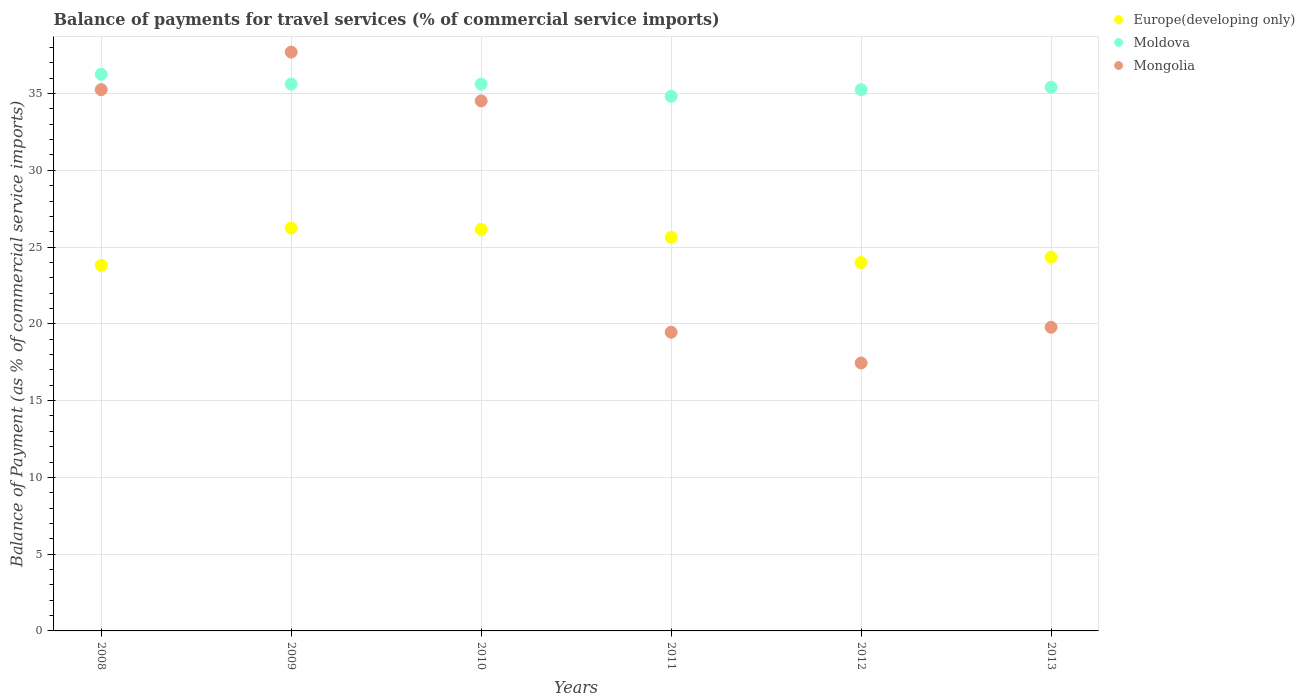What is the balance of payments for travel services in Europe(developing only) in 2009?
Your answer should be very brief. 26.24. Across all years, what is the maximum balance of payments for travel services in Moldova?
Keep it short and to the point. 36.26. Across all years, what is the minimum balance of payments for travel services in Moldova?
Provide a short and direct response. 34.82. In which year was the balance of payments for travel services in Europe(developing only) minimum?
Provide a succinct answer. 2008. What is the total balance of payments for travel services in Mongolia in the graph?
Make the answer very short. 164.17. What is the difference between the balance of payments for travel services in Mongolia in 2008 and that in 2013?
Your response must be concise. 15.47. What is the difference between the balance of payments for travel services in Europe(developing only) in 2012 and the balance of payments for travel services in Mongolia in 2010?
Ensure brevity in your answer.  -10.53. What is the average balance of payments for travel services in Moldova per year?
Offer a very short reply. 35.5. In the year 2010, what is the difference between the balance of payments for travel services in Europe(developing only) and balance of payments for travel services in Mongolia?
Offer a very short reply. -8.37. What is the ratio of the balance of payments for travel services in Europe(developing only) in 2008 to that in 2010?
Provide a succinct answer. 0.91. Is the balance of payments for travel services in Moldova in 2012 less than that in 2013?
Give a very brief answer. Yes. What is the difference between the highest and the second highest balance of payments for travel services in Moldova?
Your answer should be compact. 0.64. What is the difference between the highest and the lowest balance of payments for travel services in Mongolia?
Give a very brief answer. 20.25. Is it the case that in every year, the sum of the balance of payments for travel services in Mongolia and balance of payments for travel services in Europe(developing only)  is greater than the balance of payments for travel services in Moldova?
Your answer should be very brief. Yes. Is the balance of payments for travel services in Moldova strictly less than the balance of payments for travel services in Europe(developing only) over the years?
Keep it short and to the point. No. How many dotlines are there?
Provide a short and direct response. 3. Does the graph contain grids?
Ensure brevity in your answer.  Yes. What is the title of the graph?
Keep it short and to the point. Balance of payments for travel services (% of commercial service imports). What is the label or title of the Y-axis?
Ensure brevity in your answer.  Balance of Payment (as % of commercial service imports). What is the Balance of Payment (as % of commercial service imports) of Europe(developing only) in 2008?
Your answer should be very brief. 23.81. What is the Balance of Payment (as % of commercial service imports) of Moldova in 2008?
Offer a terse response. 36.26. What is the Balance of Payment (as % of commercial service imports) in Mongolia in 2008?
Give a very brief answer. 35.26. What is the Balance of Payment (as % of commercial service imports) in Europe(developing only) in 2009?
Your answer should be compact. 26.24. What is the Balance of Payment (as % of commercial service imports) in Moldova in 2009?
Your answer should be compact. 35.62. What is the Balance of Payment (as % of commercial service imports) in Mongolia in 2009?
Give a very brief answer. 37.7. What is the Balance of Payment (as % of commercial service imports) in Europe(developing only) in 2010?
Offer a very short reply. 26.15. What is the Balance of Payment (as % of commercial service imports) in Moldova in 2010?
Offer a very short reply. 35.61. What is the Balance of Payment (as % of commercial service imports) of Mongolia in 2010?
Ensure brevity in your answer.  34.52. What is the Balance of Payment (as % of commercial service imports) of Europe(developing only) in 2011?
Offer a terse response. 25.63. What is the Balance of Payment (as % of commercial service imports) in Moldova in 2011?
Provide a succinct answer. 34.82. What is the Balance of Payment (as % of commercial service imports) of Mongolia in 2011?
Offer a terse response. 19.45. What is the Balance of Payment (as % of commercial service imports) of Europe(developing only) in 2012?
Your answer should be compact. 24. What is the Balance of Payment (as % of commercial service imports) in Moldova in 2012?
Provide a succinct answer. 35.25. What is the Balance of Payment (as % of commercial service imports) of Mongolia in 2012?
Provide a short and direct response. 17.45. What is the Balance of Payment (as % of commercial service imports) of Europe(developing only) in 2013?
Provide a short and direct response. 24.35. What is the Balance of Payment (as % of commercial service imports) of Moldova in 2013?
Provide a succinct answer. 35.42. What is the Balance of Payment (as % of commercial service imports) of Mongolia in 2013?
Your response must be concise. 19.78. Across all years, what is the maximum Balance of Payment (as % of commercial service imports) of Europe(developing only)?
Ensure brevity in your answer.  26.24. Across all years, what is the maximum Balance of Payment (as % of commercial service imports) of Moldova?
Provide a succinct answer. 36.26. Across all years, what is the maximum Balance of Payment (as % of commercial service imports) of Mongolia?
Keep it short and to the point. 37.7. Across all years, what is the minimum Balance of Payment (as % of commercial service imports) in Europe(developing only)?
Give a very brief answer. 23.81. Across all years, what is the minimum Balance of Payment (as % of commercial service imports) of Moldova?
Offer a terse response. 34.82. Across all years, what is the minimum Balance of Payment (as % of commercial service imports) in Mongolia?
Offer a very short reply. 17.45. What is the total Balance of Payment (as % of commercial service imports) of Europe(developing only) in the graph?
Offer a terse response. 150.17. What is the total Balance of Payment (as % of commercial service imports) in Moldova in the graph?
Provide a succinct answer. 212.97. What is the total Balance of Payment (as % of commercial service imports) of Mongolia in the graph?
Ensure brevity in your answer.  164.17. What is the difference between the Balance of Payment (as % of commercial service imports) of Europe(developing only) in 2008 and that in 2009?
Your answer should be compact. -2.43. What is the difference between the Balance of Payment (as % of commercial service imports) of Moldova in 2008 and that in 2009?
Make the answer very short. 0.64. What is the difference between the Balance of Payment (as % of commercial service imports) of Mongolia in 2008 and that in 2009?
Provide a succinct answer. -2.44. What is the difference between the Balance of Payment (as % of commercial service imports) in Europe(developing only) in 2008 and that in 2010?
Make the answer very short. -2.35. What is the difference between the Balance of Payment (as % of commercial service imports) in Moldova in 2008 and that in 2010?
Offer a very short reply. 0.64. What is the difference between the Balance of Payment (as % of commercial service imports) of Mongolia in 2008 and that in 2010?
Keep it short and to the point. 0.73. What is the difference between the Balance of Payment (as % of commercial service imports) in Europe(developing only) in 2008 and that in 2011?
Ensure brevity in your answer.  -1.82. What is the difference between the Balance of Payment (as % of commercial service imports) in Moldova in 2008 and that in 2011?
Your answer should be very brief. 1.44. What is the difference between the Balance of Payment (as % of commercial service imports) in Mongolia in 2008 and that in 2011?
Give a very brief answer. 15.8. What is the difference between the Balance of Payment (as % of commercial service imports) in Europe(developing only) in 2008 and that in 2012?
Your response must be concise. -0.19. What is the difference between the Balance of Payment (as % of commercial service imports) in Moldova in 2008 and that in 2012?
Provide a short and direct response. 1. What is the difference between the Balance of Payment (as % of commercial service imports) of Mongolia in 2008 and that in 2012?
Keep it short and to the point. 17.8. What is the difference between the Balance of Payment (as % of commercial service imports) in Europe(developing only) in 2008 and that in 2013?
Offer a very short reply. -0.54. What is the difference between the Balance of Payment (as % of commercial service imports) in Moldova in 2008 and that in 2013?
Make the answer very short. 0.84. What is the difference between the Balance of Payment (as % of commercial service imports) of Mongolia in 2008 and that in 2013?
Your answer should be very brief. 15.47. What is the difference between the Balance of Payment (as % of commercial service imports) in Europe(developing only) in 2009 and that in 2010?
Offer a terse response. 0.08. What is the difference between the Balance of Payment (as % of commercial service imports) in Moldova in 2009 and that in 2010?
Ensure brevity in your answer.  0. What is the difference between the Balance of Payment (as % of commercial service imports) of Mongolia in 2009 and that in 2010?
Offer a terse response. 3.18. What is the difference between the Balance of Payment (as % of commercial service imports) in Europe(developing only) in 2009 and that in 2011?
Provide a succinct answer. 0.61. What is the difference between the Balance of Payment (as % of commercial service imports) in Moldova in 2009 and that in 2011?
Provide a succinct answer. 0.8. What is the difference between the Balance of Payment (as % of commercial service imports) of Mongolia in 2009 and that in 2011?
Offer a very short reply. 18.25. What is the difference between the Balance of Payment (as % of commercial service imports) of Europe(developing only) in 2009 and that in 2012?
Make the answer very short. 2.24. What is the difference between the Balance of Payment (as % of commercial service imports) in Moldova in 2009 and that in 2012?
Offer a terse response. 0.37. What is the difference between the Balance of Payment (as % of commercial service imports) in Mongolia in 2009 and that in 2012?
Provide a short and direct response. 20.25. What is the difference between the Balance of Payment (as % of commercial service imports) of Europe(developing only) in 2009 and that in 2013?
Give a very brief answer. 1.89. What is the difference between the Balance of Payment (as % of commercial service imports) in Moldova in 2009 and that in 2013?
Your answer should be very brief. 0.2. What is the difference between the Balance of Payment (as % of commercial service imports) in Mongolia in 2009 and that in 2013?
Keep it short and to the point. 17.92. What is the difference between the Balance of Payment (as % of commercial service imports) of Europe(developing only) in 2010 and that in 2011?
Keep it short and to the point. 0.53. What is the difference between the Balance of Payment (as % of commercial service imports) of Moldova in 2010 and that in 2011?
Your answer should be very brief. 0.8. What is the difference between the Balance of Payment (as % of commercial service imports) in Mongolia in 2010 and that in 2011?
Offer a very short reply. 15.07. What is the difference between the Balance of Payment (as % of commercial service imports) of Europe(developing only) in 2010 and that in 2012?
Provide a succinct answer. 2.16. What is the difference between the Balance of Payment (as % of commercial service imports) of Moldova in 2010 and that in 2012?
Give a very brief answer. 0.36. What is the difference between the Balance of Payment (as % of commercial service imports) in Mongolia in 2010 and that in 2012?
Provide a short and direct response. 17.07. What is the difference between the Balance of Payment (as % of commercial service imports) of Europe(developing only) in 2010 and that in 2013?
Offer a terse response. 1.81. What is the difference between the Balance of Payment (as % of commercial service imports) of Moldova in 2010 and that in 2013?
Your answer should be very brief. 0.2. What is the difference between the Balance of Payment (as % of commercial service imports) of Mongolia in 2010 and that in 2013?
Your answer should be compact. 14.74. What is the difference between the Balance of Payment (as % of commercial service imports) in Europe(developing only) in 2011 and that in 2012?
Your answer should be very brief. 1.63. What is the difference between the Balance of Payment (as % of commercial service imports) of Moldova in 2011 and that in 2012?
Your response must be concise. -0.43. What is the difference between the Balance of Payment (as % of commercial service imports) of Mongolia in 2011 and that in 2012?
Give a very brief answer. 2. What is the difference between the Balance of Payment (as % of commercial service imports) in Europe(developing only) in 2011 and that in 2013?
Your answer should be very brief. 1.28. What is the difference between the Balance of Payment (as % of commercial service imports) in Moldova in 2011 and that in 2013?
Offer a terse response. -0.6. What is the difference between the Balance of Payment (as % of commercial service imports) of Mongolia in 2011 and that in 2013?
Ensure brevity in your answer.  -0.33. What is the difference between the Balance of Payment (as % of commercial service imports) of Europe(developing only) in 2012 and that in 2013?
Give a very brief answer. -0.35. What is the difference between the Balance of Payment (as % of commercial service imports) in Moldova in 2012 and that in 2013?
Your answer should be compact. -0.17. What is the difference between the Balance of Payment (as % of commercial service imports) in Mongolia in 2012 and that in 2013?
Give a very brief answer. -2.33. What is the difference between the Balance of Payment (as % of commercial service imports) in Europe(developing only) in 2008 and the Balance of Payment (as % of commercial service imports) in Moldova in 2009?
Offer a very short reply. -11.81. What is the difference between the Balance of Payment (as % of commercial service imports) in Europe(developing only) in 2008 and the Balance of Payment (as % of commercial service imports) in Mongolia in 2009?
Keep it short and to the point. -13.89. What is the difference between the Balance of Payment (as % of commercial service imports) of Moldova in 2008 and the Balance of Payment (as % of commercial service imports) of Mongolia in 2009?
Offer a terse response. -1.45. What is the difference between the Balance of Payment (as % of commercial service imports) of Europe(developing only) in 2008 and the Balance of Payment (as % of commercial service imports) of Moldova in 2010?
Make the answer very short. -11.8. What is the difference between the Balance of Payment (as % of commercial service imports) in Europe(developing only) in 2008 and the Balance of Payment (as % of commercial service imports) in Mongolia in 2010?
Make the answer very short. -10.72. What is the difference between the Balance of Payment (as % of commercial service imports) of Moldova in 2008 and the Balance of Payment (as % of commercial service imports) of Mongolia in 2010?
Your response must be concise. 1.73. What is the difference between the Balance of Payment (as % of commercial service imports) in Europe(developing only) in 2008 and the Balance of Payment (as % of commercial service imports) in Moldova in 2011?
Offer a terse response. -11.01. What is the difference between the Balance of Payment (as % of commercial service imports) of Europe(developing only) in 2008 and the Balance of Payment (as % of commercial service imports) of Mongolia in 2011?
Your answer should be compact. 4.36. What is the difference between the Balance of Payment (as % of commercial service imports) in Moldova in 2008 and the Balance of Payment (as % of commercial service imports) in Mongolia in 2011?
Keep it short and to the point. 16.8. What is the difference between the Balance of Payment (as % of commercial service imports) in Europe(developing only) in 2008 and the Balance of Payment (as % of commercial service imports) in Moldova in 2012?
Provide a short and direct response. -11.44. What is the difference between the Balance of Payment (as % of commercial service imports) of Europe(developing only) in 2008 and the Balance of Payment (as % of commercial service imports) of Mongolia in 2012?
Offer a terse response. 6.36. What is the difference between the Balance of Payment (as % of commercial service imports) of Moldova in 2008 and the Balance of Payment (as % of commercial service imports) of Mongolia in 2012?
Give a very brief answer. 18.8. What is the difference between the Balance of Payment (as % of commercial service imports) of Europe(developing only) in 2008 and the Balance of Payment (as % of commercial service imports) of Moldova in 2013?
Keep it short and to the point. -11.61. What is the difference between the Balance of Payment (as % of commercial service imports) of Europe(developing only) in 2008 and the Balance of Payment (as % of commercial service imports) of Mongolia in 2013?
Provide a succinct answer. 4.03. What is the difference between the Balance of Payment (as % of commercial service imports) in Moldova in 2008 and the Balance of Payment (as % of commercial service imports) in Mongolia in 2013?
Your response must be concise. 16.47. What is the difference between the Balance of Payment (as % of commercial service imports) of Europe(developing only) in 2009 and the Balance of Payment (as % of commercial service imports) of Moldova in 2010?
Your answer should be very brief. -9.38. What is the difference between the Balance of Payment (as % of commercial service imports) in Europe(developing only) in 2009 and the Balance of Payment (as % of commercial service imports) in Mongolia in 2010?
Give a very brief answer. -8.29. What is the difference between the Balance of Payment (as % of commercial service imports) of Moldova in 2009 and the Balance of Payment (as % of commercial service imports) of Mongolia in 2010?
Give a very brief answer. 1.09. What is the difference between the Balance of Payment (as % of commercial service imports) in Europe(developing only) in 2009 and the Balance of Payment (as % of commercial service imports) in Moldova in 2011?
Your response must be concise. -8.58. What is the difference between the Balance of Payment (as % of commercial service imports) in Europe(developing only) in 2009 and the Balance of Payment (as % of commercial service imports) in Mongolia in 2011?
Make the answer very short. 6.78. What is the difference between the Balance of Payment (as % of commercial service imports) of Moldova in 2009 and the Balance of Payment (as % of commercial service imports) of Mongolia in 2011?
Your answer should be very brief. 16.16. What is the difference between the Balance of Payment (as % of commercial service imports) in Europe(developing only) in 2009 and the Balance of Payment (as % of commercial service imports) in Moldova in 2012?
Offer a terse response. -9.01. What is the difference between the Balance of Payment (as % of commercial service imports) of Europe(developing only) in 2009 and the Balance of Payment (as % of commercial service imports) of Mongolia in 2012?
Give a very brief answer. 8.78. What is the difference between the Balance of Payment (as % of commercial service imports) in Moldova in 2009 and the Balance of Payment (as % of commercial service imports) in Mongolia in 2012?
Make the answer very short. 18.17. What is the difference between the Balance of Payment (as % of commercial service imports) of Europe(developing only) in 2009 and the Balance of Payment (as % of commercial service imports) of Moldova in 2013?
Keep it short and to the point. -9.18. What is the difference between the Balance of Payment (as % of commercial service imports) of Europe(developing only) in 2009 and the Balance of Payment (as % of commercial service imports) of Mongolia in 2013?
Your answer should be compact. 6.46. What is the difference between the Balance of Payment (as % of commercial service imports) of Moldova in 2009 and the Balance of Payment (as % of commercial service imports) of Mongolia in 2013?
Your answer should be compact. 15.84. What is the difference between the Balance of Payment (as % of commercial service imports) in Europe(developing only) in 2010 and the Balance of Payment (as % of commercial service imports) in Moldova in 2011?
Keep it short and to the point. -8.66. What is the difference between the Balance of Payment (as % of commercial service imports) of Europe(developing only) in 2010 and the Balance of Payment (as % of commercial service imports) of Mongolia in 2011?
Keep it short and to the point. 6.7. What is the difference between the Balance of Payment (as % of commercial service imports) in Moldova in 2010 and the Balance of Payment (as % of commercial service imports) in Mongolia in 2011?
Provide a short and direct response. 16.16. What is the difference between the Balance of Payment (as % of commercial service imports) of Europe(developing only) in 2010 and the Balance of Payment (as % of commercial service imports) of Moldova in 2012?
Keep it short and to the point. -9.1. What is the difference between the Balance of Payment (as % of commercial service imports) of Europe(developing only) in 2010 and the Balance of Payment (as % of commercial service imports) of Mongolia in 2012?
Keep it short and to the point. 8.7. What is the difference between the Balance of Payment (as % of commercial service imports) in Moldova in 2010 and the Balance of Payment (as % of commercial service imports) in Mongolia in 2012?
Offer a very short reply. 18.16. What is the difference between the Balance of Payment (as % of commercial service imports) of Europe(developing only) in 2010 and the Balance of Payment (as % of commercial service imports) of Moldova in 2013?
Give a very brief answer. -9.26. What is the difference between the Balance of Payment (as % of commercial service imports) in Europe(developing only) in 2010 and the Balance of Payment (as % of commercial service imports) in Mongolia in 2013?
Ensure brevity in your answer.  6.37. What is the difference between the Balance of Payment (as % of commercial service imports) in Moldova in 2010 and the Balance of Payment (as % of commercial service imports) in Mongolia in 2013?
Offer a terse response. 15.83. What is the difference between the Balance of Payment (as % of commercial service imports) of Europe(developing only) in 2011 and the Balance of Payment (as % of commercial service imports) of Moldova in 2012?
Provide a succinct answer. -9.62. What is the difference between the Balance of Payment (as % of commercial service imports) of Europe(developing only) in 2011 and the Balance of Payment (as % of commercial service imports) of Mongolia in 2012?
Offer a terse response. 8.18. What is the difference between the Balance of Payment (as % of commercial service imports) in Moldova in 2011 and the Balance of Payment (as % of commercial service imports) in Mongolia in 2012?
Make the answer very short. 17.37. What is the difference between the Balance of Payment (as % of commercial service imports) in Europe(developing only) in 2011 and the Balance of Payment (as % of commercial service imports) in Moldova in 2013?
Provide a short and direct response. -9.79. What is the difference between the Balance of Payment (as % of commercial service imports) in Europe(developing only) in 2011 and the Balance of Payment (as % of commercial service imports) in Mongolia in 2013?
Give a very brief answer. 5.85. What is the difference between the Balance of Payment (as % of commercial service imports) in Moldova in 2011 and the Balance of Payment (as % of commercial service imports) in Mongolia in 2013?
Offer a very short reply. 15.04. What is the difference between the Balance of Payment (as % of commercial service imports) in Europe(developing only) in 2012 and the Balance of Payment (as % of commercial service imports) in Moldova in 2013?
Make the answer very short. -11.42. What is the difference between the Balance of Payment (as % of commercial service imports) of Europe(developing only) in 2012 and the Balance of Payment (as % of commercial service imports) of Mongolia in 2013?
Keep it short and to the point. 4.21. What is the difference between the Balance of Payment (as % of commercial service imports) in Moldova in 2012 and the Balance of Payment (as % of commercial service imports) in Mongolia in 2013?
Your answer should be compact. 15.47. What is the average Balance of Payment (as % of commercial service imports) in Europe(developing only) per year?
Ensure brevity in your answer.  25.03. What is the average Balance of Payment (as % of commercial service imports) in Moldova per year?
Make the answer very short. 35.5. What is the average Balance of Payment (as % of commercial service imports) of Mongolia per year?
Your answer should be compact. 27.36. In the year 2008, what is the difference between the Balance of Payment (as % of commercial service imports) of Europe(developing only) and Balance of Payment (as % of commercial service imports) of Moldova?
Ensure brevity in your answer.  -12.45. In the year 2008, what is the difference between the Balance of Payment (as % of commercial service imports) of Europe(developing only) and Balance of Payment (as % of commercial service imports) of Mongolia?
Provide a short and direct response. -11.45. In the year 2009, what is the difference between the Balance of Payment (as % of commercial service imports) in Europe(developing only) and Balance of Payment (as % of commercial service imports) in Moldova?
Keep it short and to the point. -9.38. In the year 2009, what is the difference between the Balance of Payment (as % of commercial service imports) in Europe(developing only) and Balance of Payment (as % of commercial service imports) in Mongolia?
Your answer should be very brief. -11.46. In the year 2009, what is the difference between the Balance of Payment (as % of commercial service imports) of Moldova and Balance of Payment (as % of commercial service imports) of Mongolia?
Offer a very short reply. -2.08. In the year 2010, what is the difference between the Balance of Payment (as % of commercial service imports) in Europe(developing only) and Balance of Payment (as % of commercial service imports) in Moldova?
Keep it short and to the point. -9.46. In the year 2010, what is the difference between the Balance of Payment (as % of commercial service imports) of Europe(developing only) and Balance of Payment (as % of commercial service imports) of Mongolia?
Keep it short and to the point. -8.37. In the year 2010, what is the difference between the Balance of Payment (as % of commercial service imports) of Moldova and Balance of Payment (as % of commercial service imports) of Mongolia?
Ensure brevity in your answer.  1.09. In the year 2011, what is the difference between the Balance of Payment (as % of commercial service imports) of Europe(developing only) and Balance of Payment (as % of commercial service imports) of Moldova?
Offer a very short reply. -9.19. In the year 2011, what is the difference between the Balance of Payment (as % of commercial service imports) in Europe(developing only) and Balance of Payment (as % of commercial service imports) in Mongolia?
Your response must be concise. 6.18. In the year 2011, what is the difference between the Balance of Payment (as % of commercial service imports) in Moldova and Balance of Payment (as % of commercial service imports) in Mongolia?
Provide a succinct answer. 15.36. In the year 2012, what is the difference between the Balance of Payment (as % of commercial service imports) in Europe(developing only) and Balance of Payment (as % of commercial service imports) in Moldova?
Make the answer very short. -11.26. In the year 2012, what is the difference between the Balance of Payment (as % of commercial service imports) of Europe(developing only) and Balance of Payment (as % of commercial service imports) of Mongolia?
Your response must be concise. 6.54. In the year 2012, what is the difference between the Balance of Payment (as % of commercial service imports) of Moldova and Balance of Payment (as % of commercial service imports) of Mongolia?
Your response must be concise. 17.8. In the year 2013, what is the difference between the Balance of Payment (as % of commercial service imports) of Europe(developing only) and Balance of Payment (as % of commercial service imports) of Moldova?
Make the answer very short. -11.07. In the year 2013, what is the difference between the Balance of Payment (as % of commercial service imports) of Europe(developing only) and Balance of Payment (as % of commercial service imports) of Mongolia?
Offer a terse response. 4.57. In the year 2013, what is the difference between the Balance of Payment (as % of commercial service imports) of Moldova and Balance of Payment (as % of commercial service imports) of Mongolia?
Ensure brevity in your answer.  15.63. What is the ratio of the Balance of Payment (as % of commercial service imports) in Europe(developing only) in 2008 to that in 2009?
Your answer should be compact. 0.91. What is the ratio of the Balance of Payment (as % of commercial service imports) in Moldova in 2008 to that in 2009?
Provide a succinct answer. 1.02. What is the ratio of the Balance of Payment (as % of commercial service imports) of Mongolia in 2008 to that in 2009?
Make the answer very short. 0.94. What is the ratio of the Balance of Payment (as % of commercial service imports) in Europe(developing only) in 2008 to that in 2010?
Your response must be concise. 0.91. What is the ratio of the Balance of Payment (as % of commercial service imports) in Moldova in 2008 to that in 2010?
Your response must be concise. 1.02. What is the ratio of the Balance of Payment (as % of commercial service imports) in Mongolia in 2008 to that in 2010?
Your response must be concise. 1.02. What is the ratio of the Balance of Payment (as % of commercial service imports) in Europe(developing only) in 2008 to that in 2011?
Give a very brief answer. 0.93. What is the ratio of the Balance of Payment (as % of commercial service imports) of Moldova in 2008 to that in 2011?
Provide a short and direct response. 1.04. What is the ratio of the Balance of Payment (as % of commercial service imports) in Mongolia in 2008 to that in 2011?
Provide a short and direct response. 1.81. What is the ratio of the Balance of Payment (as % of commercial service imports) of Europe(developing only) in 2008 to that in 2012?
Your answer should be very brief. 0.99. What is the ratio of the Balance of Payment (as % of commercial service imports) in Moldova in 2008 to that in 2012?
Your answer should be very brief. 1.03. What is the ratio of the Balance of Payment (as % of commercial service imports) of Mongolia in 2008 to that in 2012?
Provide a succinct answer. 2.02. What is the ratio of the Balance of Payment (as % of commercial service imports) of Moldova in 2008 to that in 2013?
Provide a succinct answer. 1.02. What is the ratio of the Balance of Payment (as % of commercial service imports) of Mongolia in 2008 to that in 2013?
Provide a succinct answer. 1.78. What is the ratio of the Balance of Payment (as % of commercial service imports) of Mongolia in 2009 to that in 2010?
Provide a succinct answer. 1.09. What is the ratio of the Balance of Payment (as % of commercial service imports) in Europe(developing only) in 2009 to that in 2011?
Offer a very short reply. 1.02. What is the ratio of the Balance of Payment (as % of commercial service imports) of Mongolia in 2009 to that in 2011?
Give a very brief answer. 1.94. What is the ratio of the Balance of Payment (as % of commercial service imports) of Europe(developing only) in 2009 to that in 2012?
Your response must be concise. 1.09. What is the ratio of the Balance of Payment (as % of commercial service imports) in Moldova in 2009 to that in 2012?
Provide a short and direct response. 1.01. What is the ratio of the Balance of Payment (as % of commercial service imports) of Mongolia in 2009 to that in 2012?
Provide a short and direct response. 2.16. What is the ratio of the Balance of Payment (as % of commercial service imports) of Europe(developing only) in 2009 to that in 2013?
Ensure brevity in your answer.  1.08. What is the ratio of the Balance of Payment (as % of commercial service imports) of Mongolia in 2009 to that in 2013?
Provide a succinct answer. 1.91. What is the ratio of the Balance of Payment (as % of commercial service imports) of Europe(developing only) in 2010 to that in 2011?
Your answer should be very brief. 1.02. What is the ratio of the Balance of Payment (as % of commercial service imports) in Moldova in 2010 to that in 2011?
Give a very brief answer. 1.02. What is the ratio of the Balance of Payment (as % of commercial service imports) of Mongolia in 2010 to that in 2011?
Ensure brevity in your answer.  1.77. What is the ratio of the Balance of Payment (as % of commercial service imports) in Europe(developing only) in 2010 to that in 2012?
Your answer should be very brief. 1.09. What is the ratio of the Balance of Payment (as % of commercial service imports) of Moldova in 2010 to that in 2012?
Keep it short and to the point. 1.01. What is the ratio of the Balance of Payment (as % of commercial service imports) in Mongolia in 2010 to that in 2012?
Your answer should be compact. 1.98. What is the ratio of the Balance of Payment (as % of commercial service imports) in Europe(developing only) in 2010 to that in 2013?
Offer a very short reply. 1.07. What is the ratio of the Balance of Payment (as % of commercial service imports) in Moldova in 2010 to that in 2013?
Ensure brevity in your answer.  1.01. What is the ratio of the Balance of Payment (as % of commercial service imports) of Mongolia in 2010 to that in 2013?
Your response must be concise. 1.75. What is the ratio of the Balance of Payment (as % of commercial service imports) in Europe(developing only) in 2011 to that in 2012?
Your response must be concise. 1.07. What is the ratio of the Balance of Payment (as % of commercial service imports) in Moldova in 2011 to that in 2012?
Offer a very short reply. 0.99. What is the ratio of the Balance of Payment (as % of commercial service imports) of Mongolia in 2011 to that in 2012?
Provide a short and direct response. 1.11. What is the ratio of the Balance of Payment (as % of commercial service imports) of Europe(developing only) in 2011 to that in 2013?
Offer a very short reply. 1.05. What is the ratio of the Balance of Payment (as % of commercial service imports) in Moldova in 2011 to that in 2013?
Your answer should be very brief. 0.98. What is the ratio of the Balance of Payment (as % of commercial service imports) of Mongolia in 2011 to that in 2013?
Ensure brevity in your answer.  0.98. What is the ratio of the Balance of Payment (as % of commercial service imports) in Europe(developing only) in 2012 to that in 2013?
Your response must be concise. 0.99. What is the ratio of the Balance of Payment (as % of commercial service imports) of Moldova in 2012 to that in 2013?
Your response must be concise. 1. What is the ratio of the Balance of Payment (as % of commercial service imports) of Mongolia in 2012 to that in 2013?
Offer a very short reply. 0.88. What is the difference between the highest and the second highest Balance of Payment (as % of commercial service imports) in Europe(developing only)?
Offer a terse response. 0.08. What is the difference between the highest and the second highest Balance of Payment (as % of commercial service imports) in Moldova?
Offer a terse response. 0.64. What is the difference between the highest and the second highest Balance of Payment (as % of commercial service imports) of Mongolia?
Keep it short and to the point. 2.44. What is the difference between the highest and the lowest Balance of Payment (as % of commercial service imports) of Europe(developing only)?
Keep it short and to the point. 2.43. What is the difference between the highest and the lowest Balance of Payment (as % of commercial service imports) in Moldova?
Your answer should be very brief. 1.44. What is the difference between the highest and the lowest Balance of Payment (as % of commercial service imports) in Mongolia?
Offer a very short reply. 20.25. 